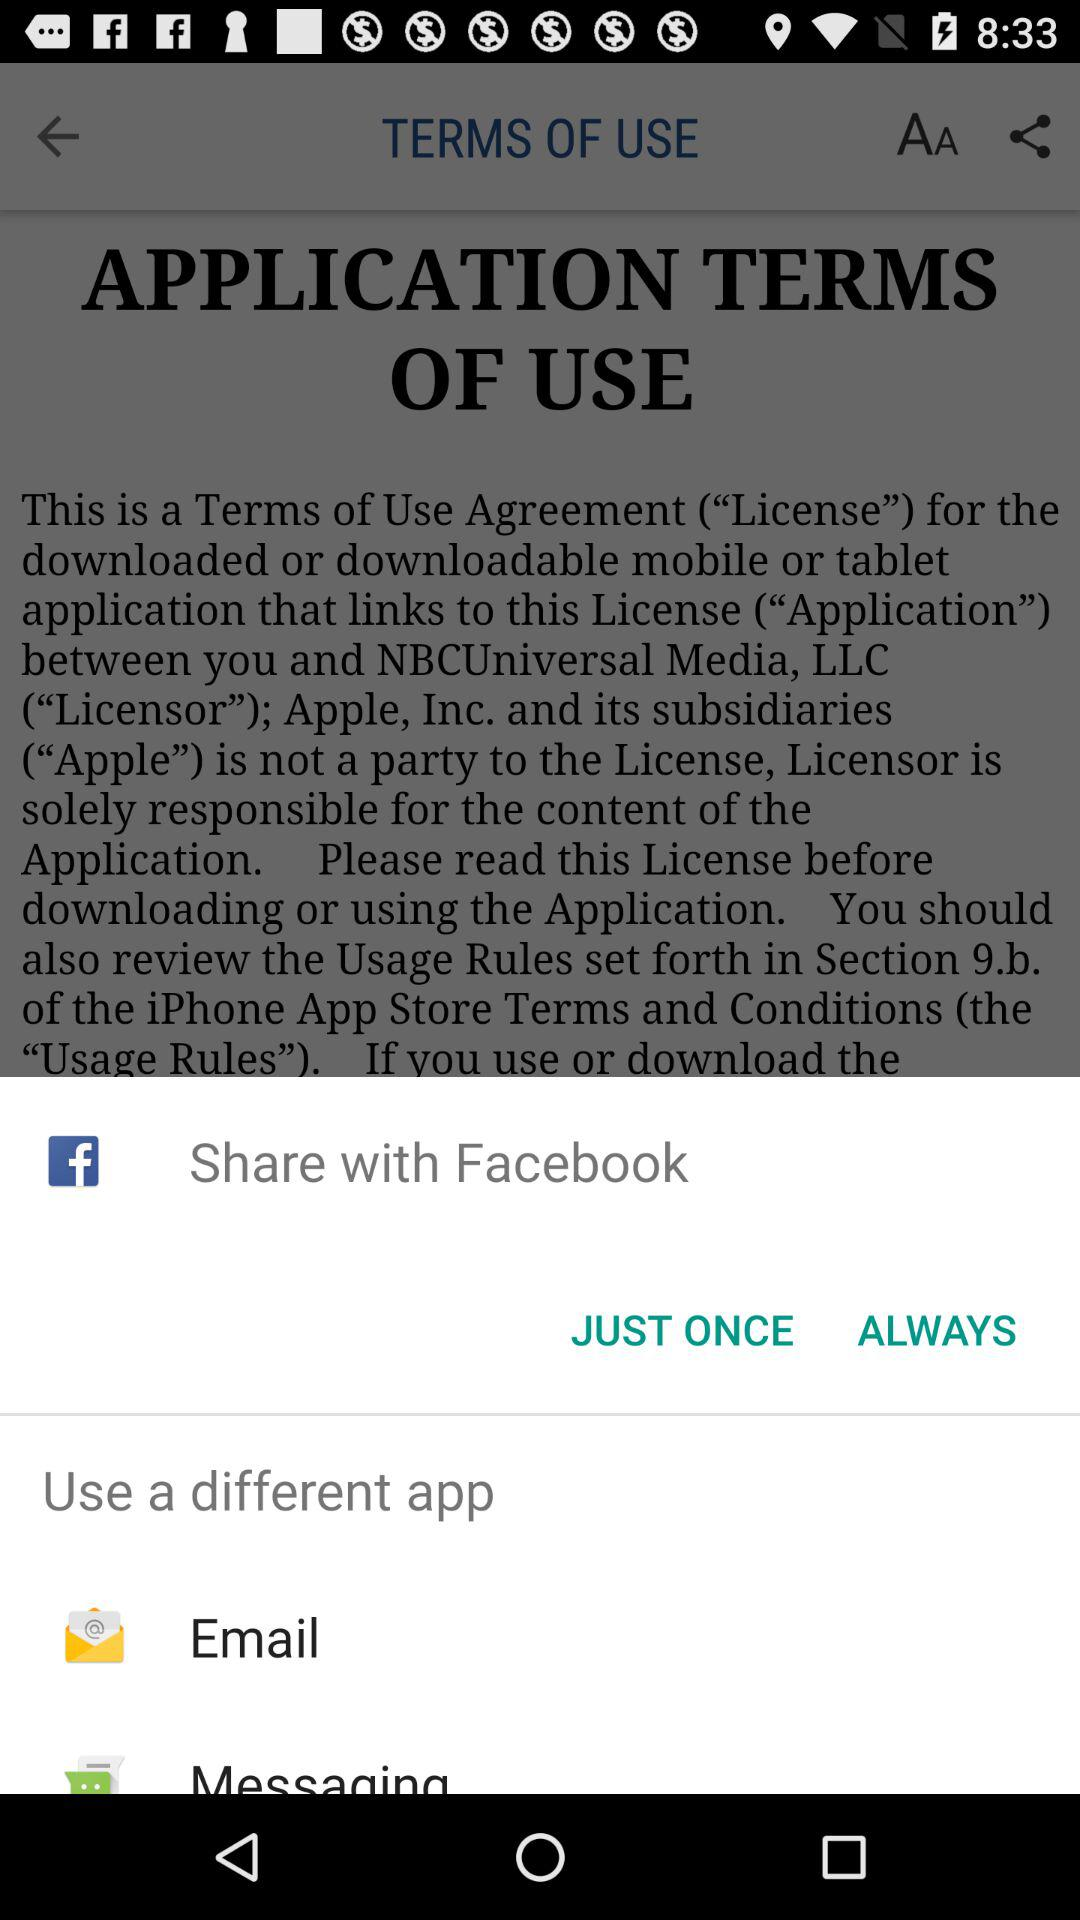What are the different apps can I use to share? You can share with "Facebook", "Email" and "Messaging". 